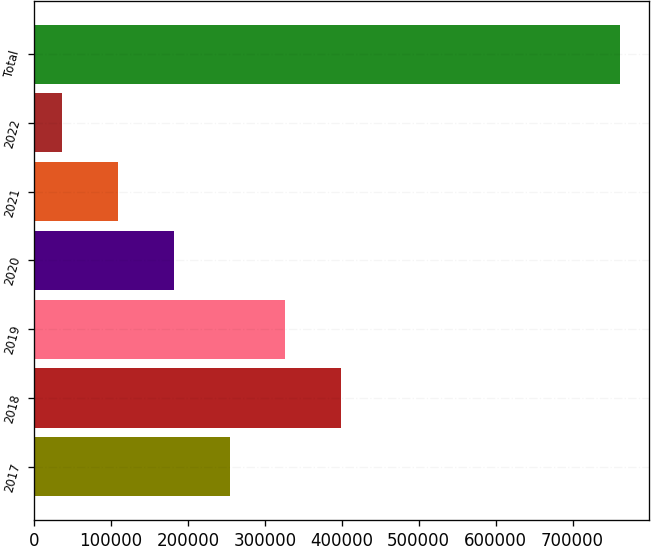Convert chart. <chart><loc_0><loc_0><loc_500><loc_500><bar_chart><fcel>2017<fcel>2018<fcel>2019<fcel>2020<fcel>2021<fcel>2022<fcel>Total<nl><fcel>254196<fcel>399074<fcel>326635<fcel>181757<fcel>109319<fcel>36880<fcel>761267<nl></chart> 